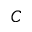<formula> <loc_0><loc_0><loc_500><loc_500>C</formula> 